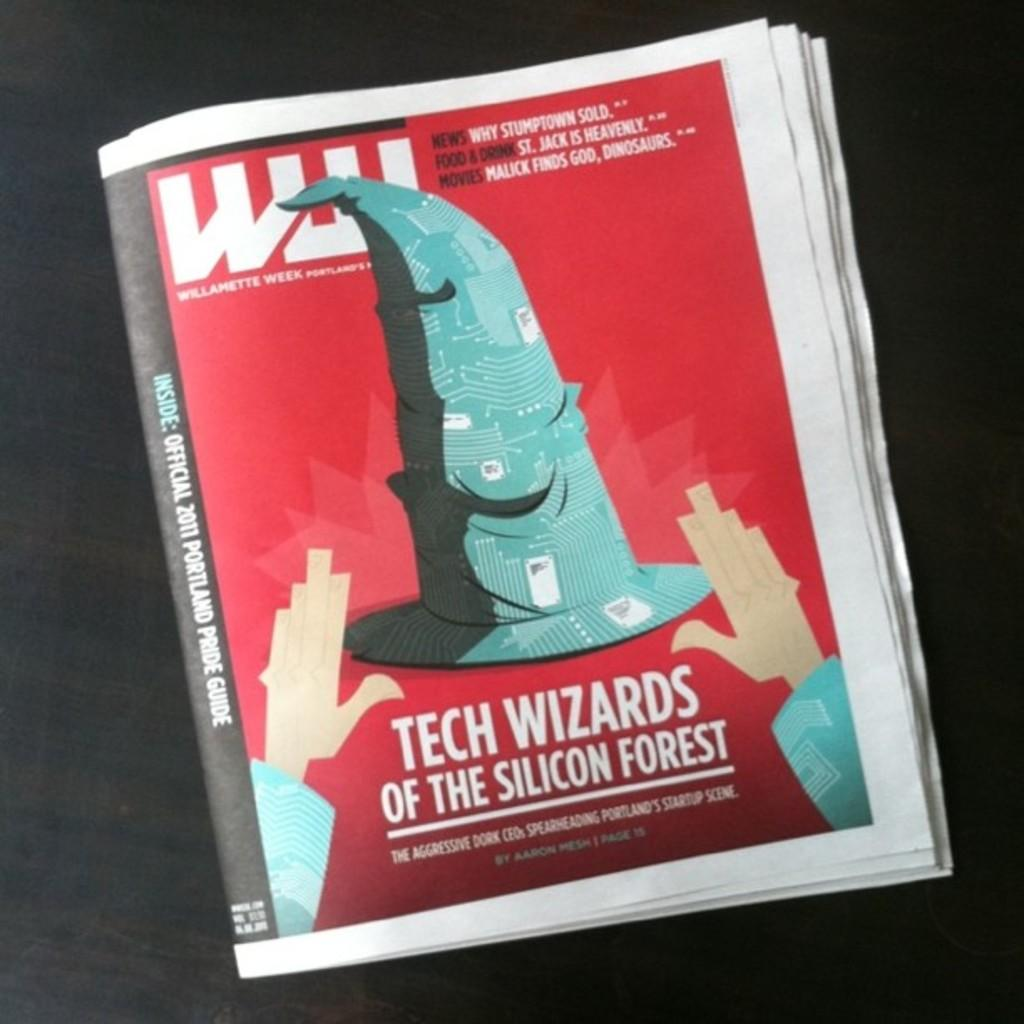<image>
Render a clear and concise summary of the photo. The front page of a magazine shows an article about tech wizards of the silicon forest. 